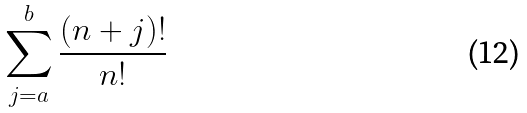<formula> <loc_0><loc_0><loc_500><loc_500>\sum _ { j = a } ^ { b } \frac { ( n + j ) ! } { n ! }</formula> 